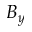<formula> <loc_0><loc_0><loc_500><loc_500>B _ { y }</formula> 